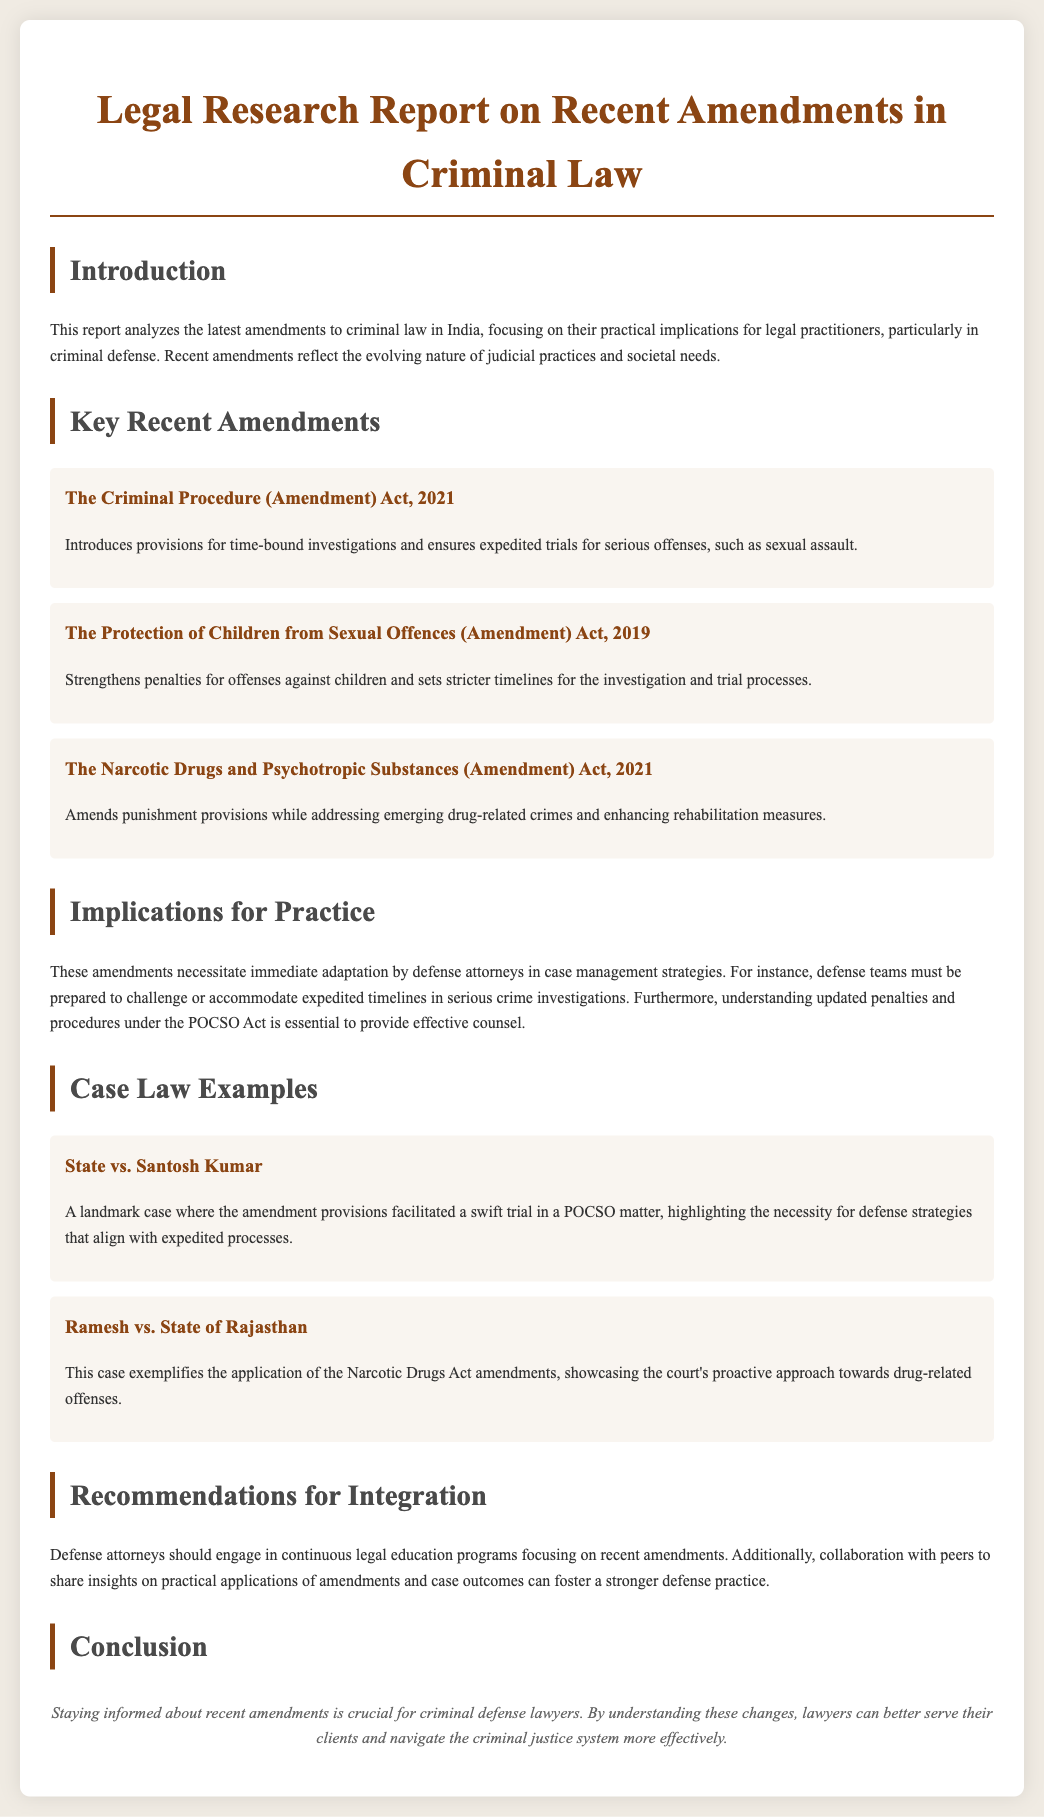What is the title of the report? The title of the report is located at the top of the document and summarizes its content.
Answer: Legal Research Report on Recent Amendments in Criminal Law What year was The Criminal Procedure (Amendment) Act enacted? The document specifies the year associated with this amendment for clear reference.
Answer: 2021 Which act strengthens penalties for offenses against children? The document discusses various amendments, including the one addressing child offenses specifically.
Answer: The Protection of Children from Sexual Offences (Amendment) Act, 2019 What is essential for defense attorneys according to the implications for practice section? The document emphasizes what defense attorneys need to adapt to amid the new amendments.
Answer: Immediate adaptation What landmark case is mentioned regarding POCSO matters? The document references a significant legal case to illustrate the impact of recent amendments.
Answer: State vs. Santosh Kumar How many amendments are highlighted in the report? The document lists and describes the amendments, providing a clear count.
Answer: Three What should defense attorneys engage in according to the recommendations? The recommendations section advises an important aspect of professional development for attorneys.
Answer: Continuous legal education programs What is the conclusion's main point? The conclusion summarises the report's findings on the importance of being informed about the amendments.
Answer: Staying informed about recent amendments 